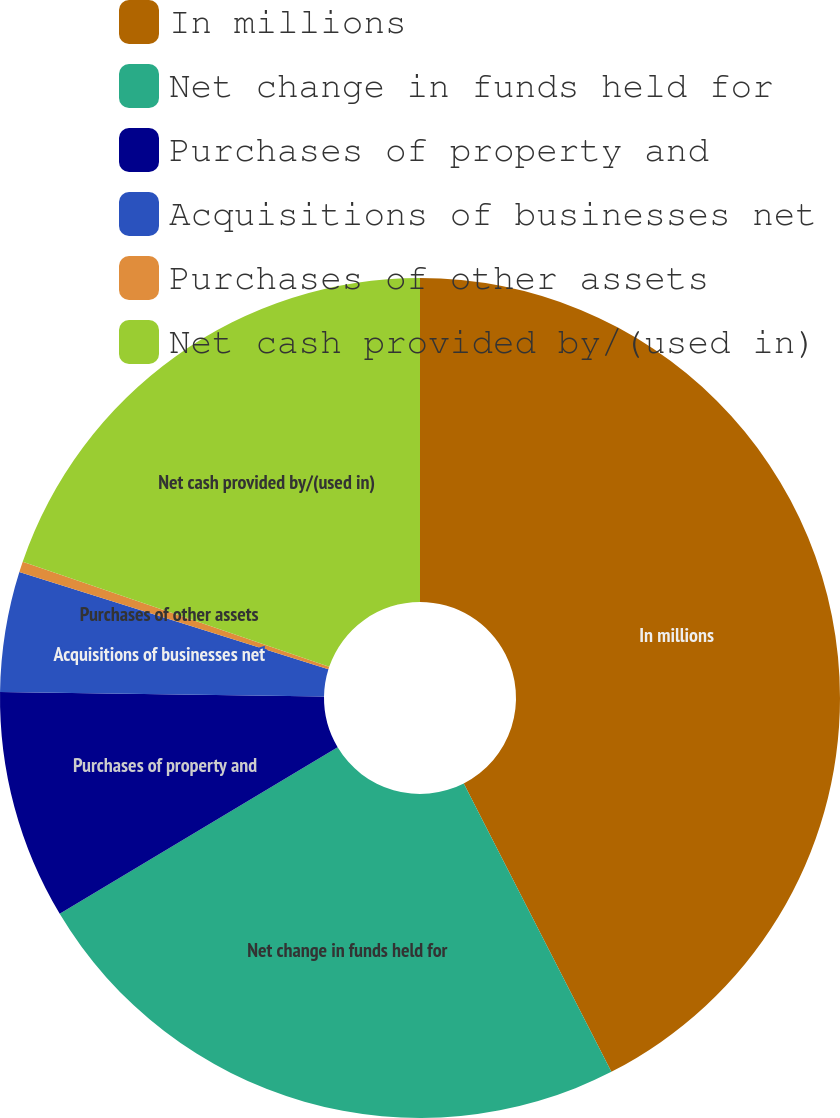Convert chart to OTSL. <chart><loc_0><loc_0><loc_500><loc_500><pie_chart><fcel>In millions<fcel>Net change in funds held for<fcel>Purchases of property and<fcel>Acquisitions of businesses net<fcel>Purchases of other assets<fcel>Net cash provided by/(used in)<nl><fcel>42.47%<fcel>23.94%<fcel>8.82%<fcel>4.62%<fcel>0.41%<fcel>19.74%<nl></chart> 